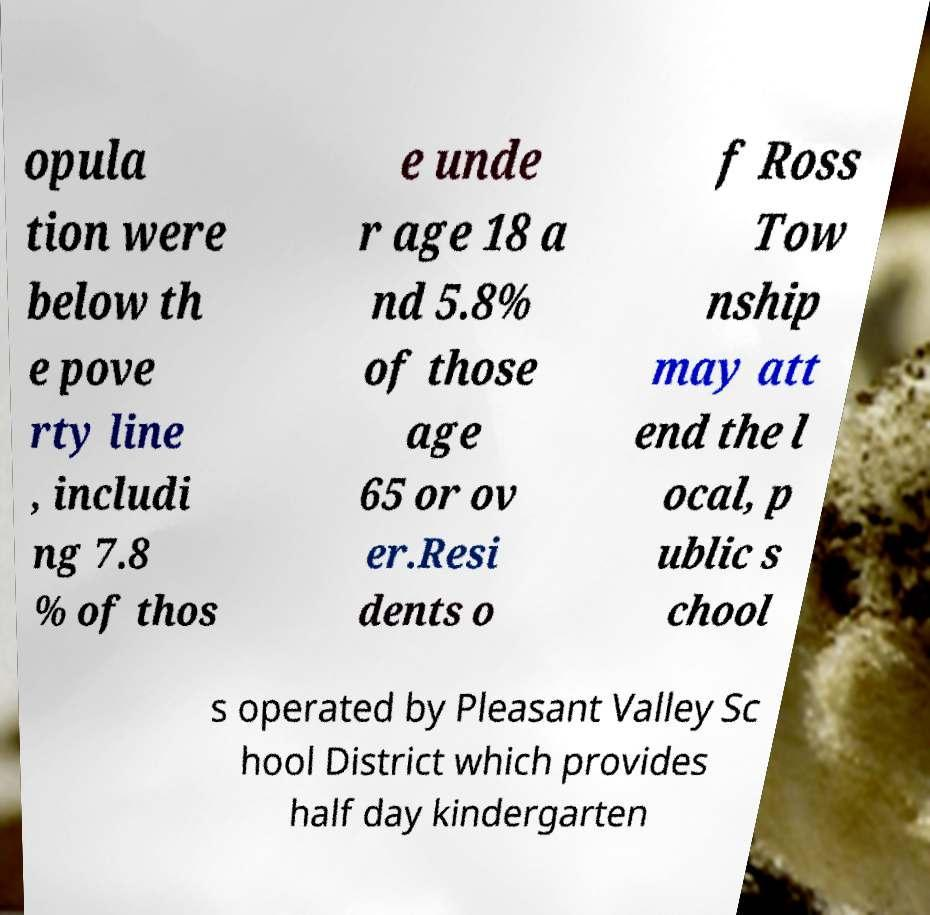There's text embedded in this image that I need extracted. Can you transcribe it verbatim? opula tion were below th e pove rty line , includi ng 7.8 % of thos e unde r age 18 a nd 5.8% of those age 65 or ov er.Resi dents o f Ross Tow nship may att end the l ocal, p ublic s chool s operated by Pleasant Valley Sc hool District which provides half day kindergarten 